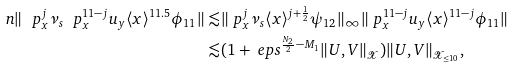Convert formula to latex. <formula><loc_0><loc_0><loc_500><loc_500>\ n \| \ p _ { x } ^ { j } \nu _ { s } \ p _ { x } ^ { 1 1 - j } u _ { y } \langle x \rangle ^ { 1 1 . 5 } \phi _ { 1 1 } \| \lesssim & \| \ p _ { x } ^ { j } \nu _ { s } \langle x \rangle ^ { j + \frac { 1 } { 2 } } \psi _ { 1 2 } \| _ { \infty } \| \ p _ { x } ^ { 1 1 - j } u _ { y } \langle x \rangle ^ { 1 1 - j } \phi _ { 1 1 } \| \\ \lesssim & ( 1 + \ e p s ^ { \frac { N _ { 2 } } { 2 } - M _ { 1 } } \| U , V \| _ { \mathcal { X } } ) \| U , V \| _ { \mathcal { X } _ { \leq 1 0 } } ,</formula> 